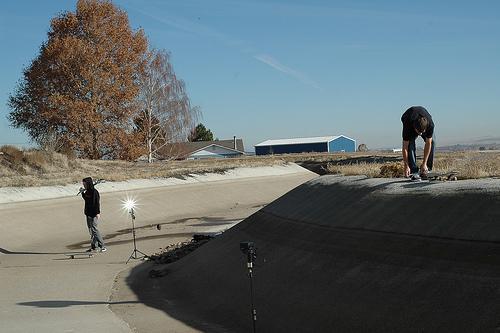How many people in photo?
Give a very brief answer. 2. 